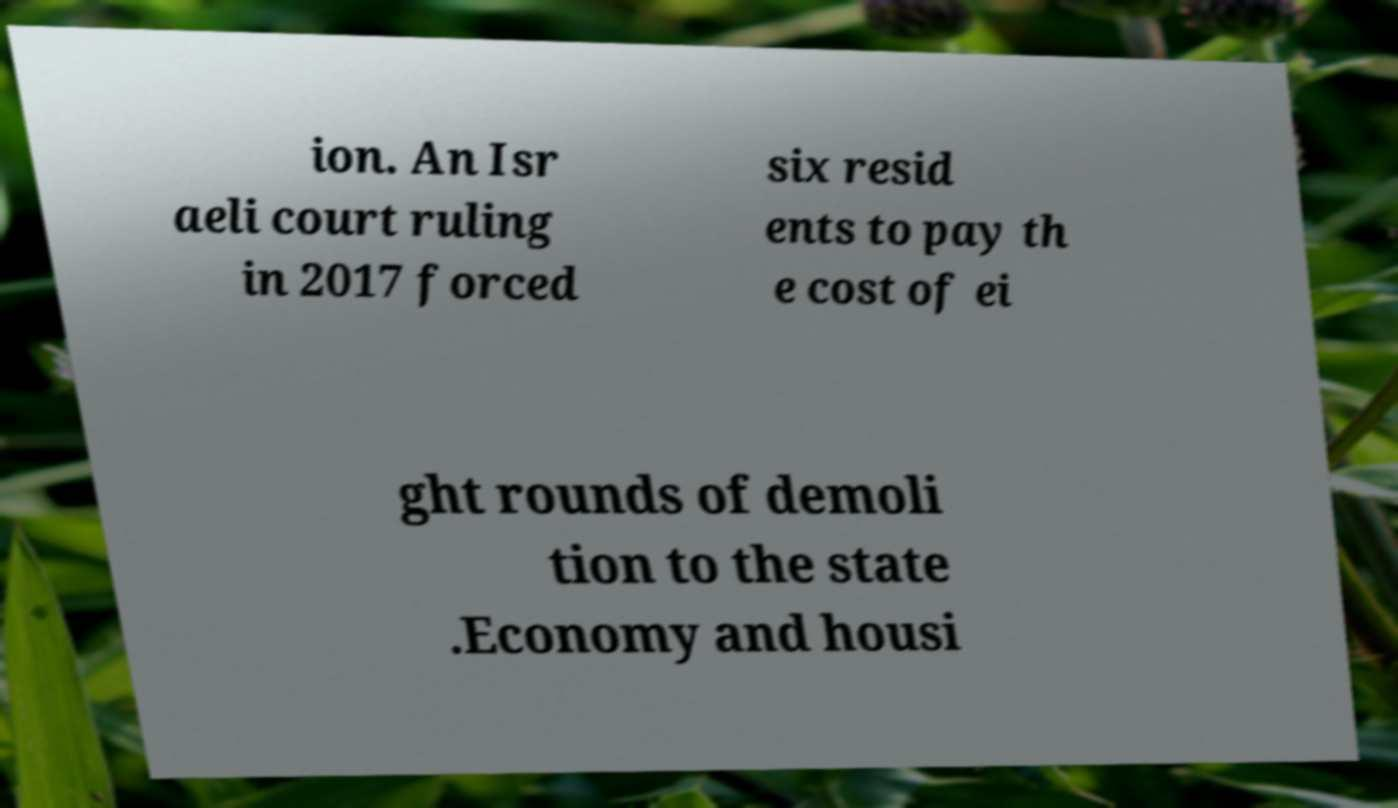Can you read and provide the text displayed in the image?This photo seems to have some interesting text. Can you extract and type it out for me? ion. An Isr aeli court ruling in 2017 forced six resid ents to pay th e cost of ei ght rounds of demoli tion to the state .Economy and housi 